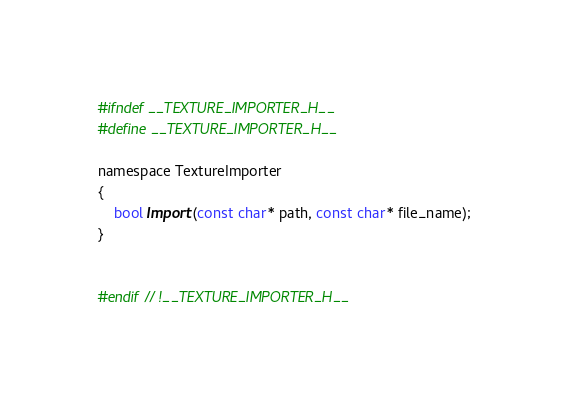Convert code to text. <code><loc_0><loc_0><loc_500><loc_500><_C_>#ifndef __TEXTURE_IMPORTER_H__
#define __TEXTURE_IMPORTER_H__

namespace TextureImporter
{
	bool Import(const char* path, const char* file_name);
}


#endif // !__TEXTURE_IMPORTER_H__
</code> 